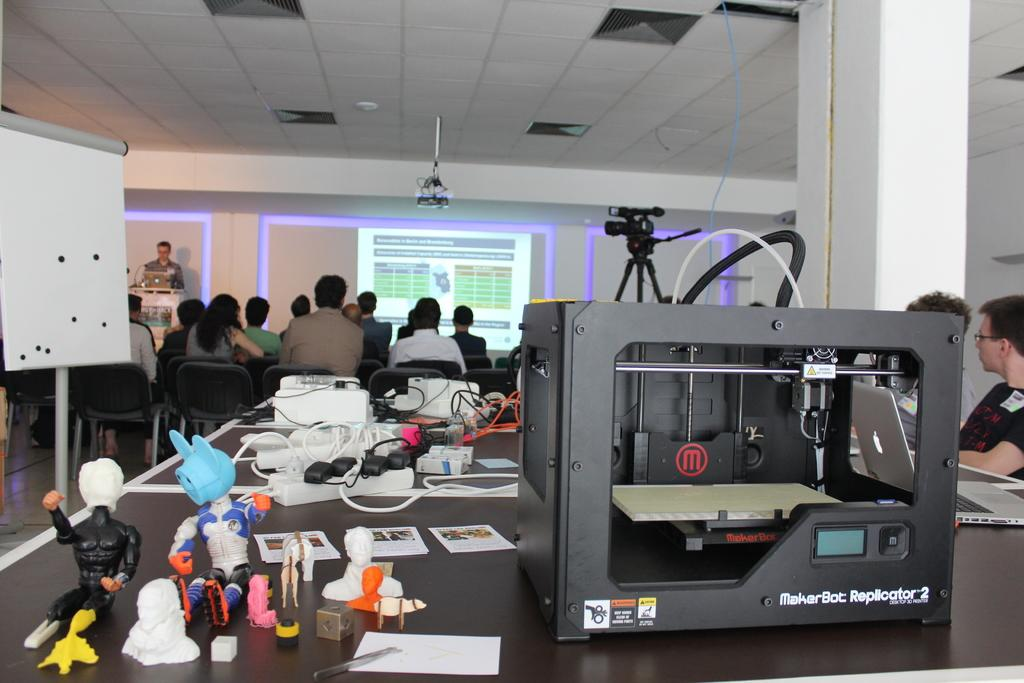<image>
Describe the image concisely. A chunky black device which has the word MakerBot on it. 